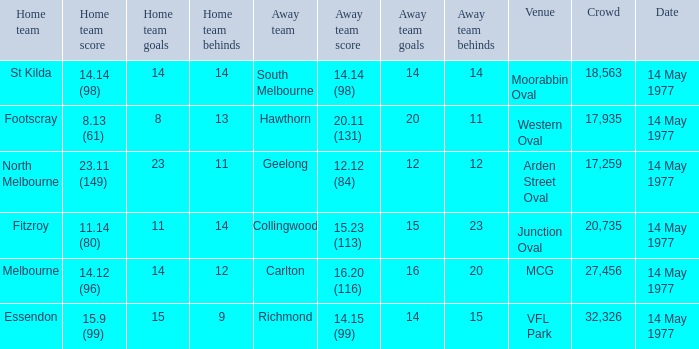How many people were in the crowd with the away team being collingwood? 1.0. 